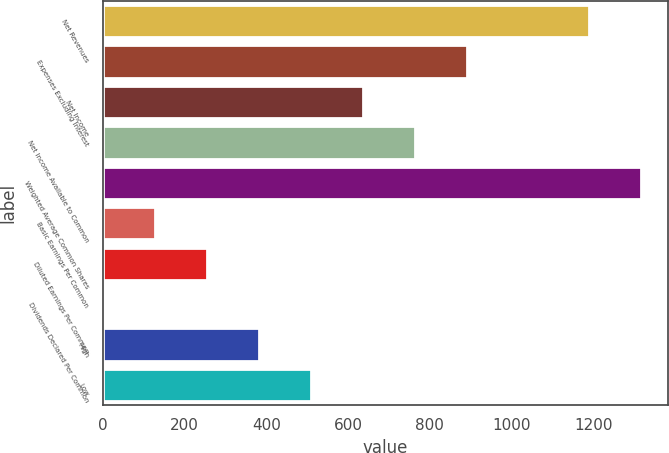<chart> <loc_0><loc_0><loc_500><loc_500><bar_chart><fcel>Net Revenues<fcel>Expenses Excluding Interest<fcel>Net Income<fcel>Net Income Available to Common<fcel>Weighted Average Common Shares<fcel>Basic Earnings Per Common<fcel>Diluted Earnings Per Common<fcel>Dividends Declared Per Common<fcel>High<fcel>Low<nl><fcel>1189<fcel>891.09<fcel>636.51<fcel>763.8<fcel>1316.29<fcel>127.35<fcel>254.64<fcel>0.06<fcel>381.93<fcel>509.22<nl></chart> 